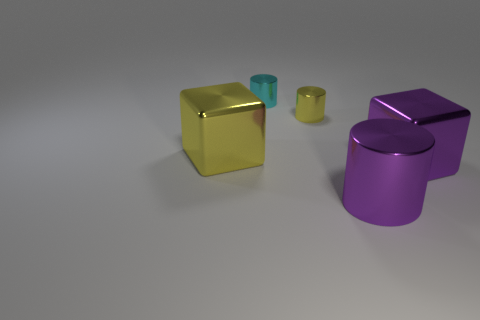Subtract all cyan shiny cylinders. How many cylinders are left? 2 Add 3 large yellow blocks. How many objects exist? 8 Subtract all cubes. How many objects are left? 3 Subtract all gray cylinders. Subtract all yellow cubes. How many cylinders are left? 3 Subtract all gray cylinders. How many purple cubes are left? 1 Subtract all big yellow blocks. Subtract all tiny yellow metal cylinders. How many objects are left? 3 Add 1 large purple shiny things. How many large purple shiny things are left? 3 Add 1 cyan cylinders. How many cyan cylinders exist? 2 Subtract all cyan cylinders. How many cylinders are left? 2 Subtract 0 brown spheres. How many objects are left? 5 